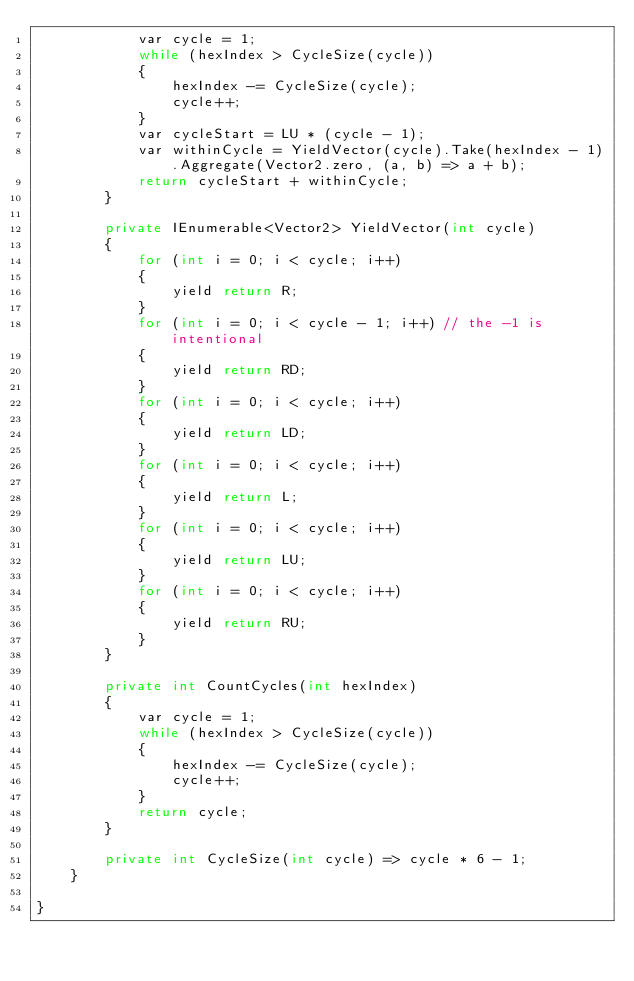<code> <loc_0><loc_0><loc_500><loc_500><_C#_>            var cycle = 1;
            while (hexIndex > CycleSize(cycle))
            {
                hexIndex -= CycleSize(cycle);
                cycle++;
            }
            var cycleStart = LU * (cycle - 1);
            var withinCycle = YieldVector(cycle).Take(hexIndex - 1).Aggregate(Vector2.zero, (a, b) => a + b);
            return cycleStart + withinCycle;
        }

        private IEnumerable<Vector2> YieldVector(int cycle)
        {
            for (int i = 0; i < cycle; i++)
            {
                yield return R;
            }
            for (int i = 0; i < cycle - 1; i++) // the -1 is intentional
            {
                yield return RD;
            }
            for (int i = 0; i < cycle; i++)
            {
                yield return LD;
            }
            for (int i = 0; i < cycle; i++)
            {
                yield return L;
            }
            for (int i = 0; i < cycle; i++)
            {
                yield return LU;
            }
            for (int i = 0; i < cycle; i++)
            {
                yield return RU;
            }
        }

        private int CountCycles(int hexIndex)
        {
            var cycle = 1;
            while (hexIndex > CycleSize(cycle))
            {
                hexIndex -= CycleSize(cycle);
                cycle++;
            }
            return cycle;
        }

        private int CycleSize(int cycle) => cycle * 6 - 1;
    }

}</code> 